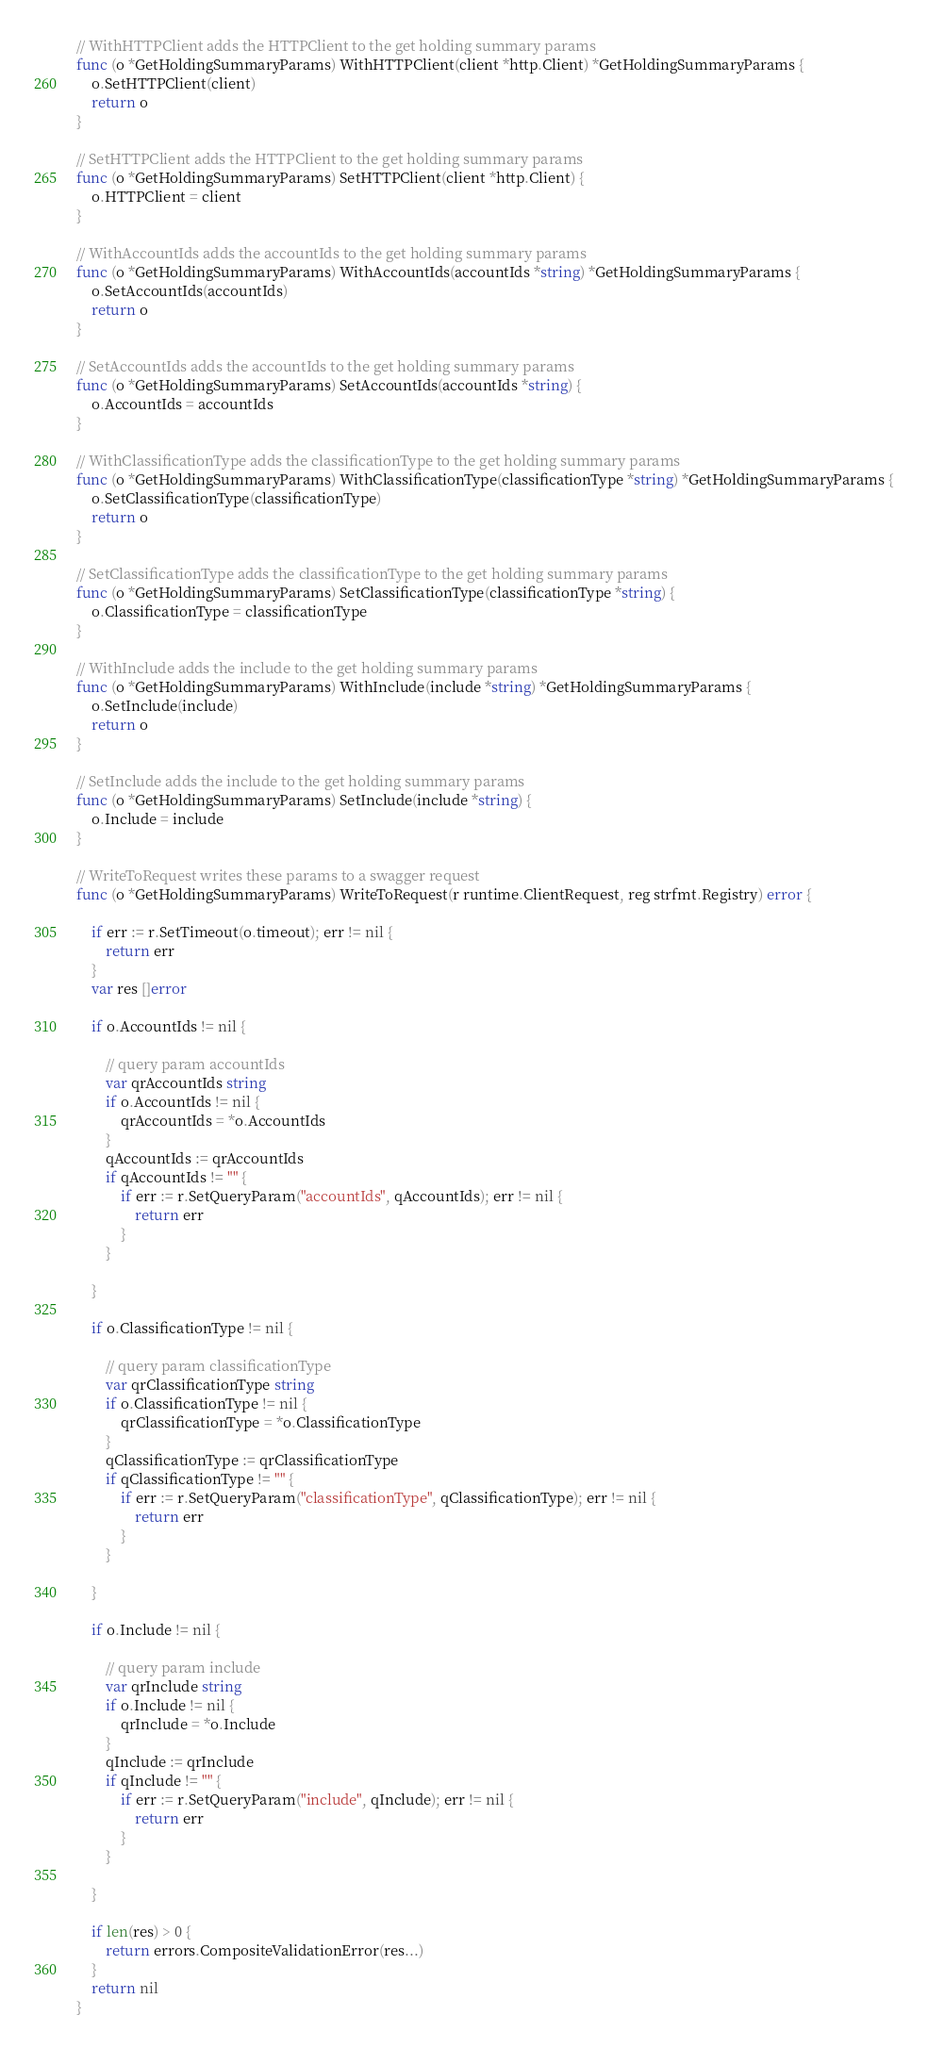<code> <loc_0><loc_0><loc_500><loc_500><_Go_>
// WithHTTPClient adds the HTTPClient to the get holding summary params
func (o *GetHoldingSummaryParams) WithHTTPClient(client *http.Client) *GetHoldingSummaryParams {
	o.SetHTTPClient(client)
	return o
}

// SetHTTPClient adds the HTTPClient to the get holding summary params
func (o *GetHoldingSummaryParams) SetHTTPClient(client *http.Client) {
	o.HTTPClient = client
}

// WithAccountIds adds the accountIds to the get holding summary params
func (o *GetHoldingSummaryParams) WithAccountIds(accountIds *string) *GetHoldingSummaryParams {
	o.SetAccountIds(accountIds)
	return o
}

// SetAccountIds adds the accountIds to the get holding summary params
func (o *GetHoldingSummaryParams) SetAccountIds(accountIds *string) {
	o.AccountIds = accountIds
}

// WithClassificationType adds the classificationType to the get holding summary params
func (o *GetHoldingSummaryParams) WithClassificationType(classificationType *string) *GetHoldingSummaryParams {
	o.SetClassificationType(classificationType)
	return o
}

// SetClassificationType adds the classificationType to the get holding summary params
func (o *GetHoldingSummaryParams) SetClassificationType(classificationType *string) {
	o.ClassificationType = classificationType
}

// WithInclude adds the include to the get holding summary params
func (o *GetHoldingSummaryParams) WithInclude(include *string) *GetHoldingSummaryParams {
	o.SetInclude(include)
	return o
}

// SetInclude adds the include to the get holding summary params
func (o *GetHoldingSummaryParams) SetInclude(include *string) {
	o.Include = include
}

// WriteToRequest writes these params to a swagger request
func (o *GetHoldingSummaryParams) WriteToRequest(r runtime.ClientRequest, reg strfmt.Registry) error {

	if err := r.SetTimeout(o.timeout); err != nil {
		return err
	}
	var res []error

	if o.AccountIds != nil {

		// query param accountIds
		var qrAccountIds string
		if o.AccountIds != nil {
			qrAccountIds = *o.AccountIds
		}
		qAccountIds := qrAccountIds
		if qAccountIds != "" {
			if err := r.SetQueryParam("accountIds", qAccountIds); err != nil {
				return err
			}
		}

	}

	if o.ClassificationType != nil {

		// query param classificationType
		var qrClassificationType string
		if o.ClassificationType != nil {
			qrClassificationType = *o.ClassificationType
		}
		qClassificationType := qrClassificationType
		if qClassificationType != "" {
			if err := r.SetQueryParam("classificationType", qClassificationType); err != nil {
				return err
			}
		}

	}

	if o.Include != nil {

		// query param include
		var qrInclude string
		if o.Include != nil {
			qrInclude = *o.Include
		}
		qInclude := qrInclude
		if qInclude != "" {
			if err := r.SetQueryParam("include", qInclude); err != nil {
				return err
			}
		}

	}

	if len(res) > 0 {
		return errors.CompositeValidationError(res...)
	}
	return nil
}
</code> 